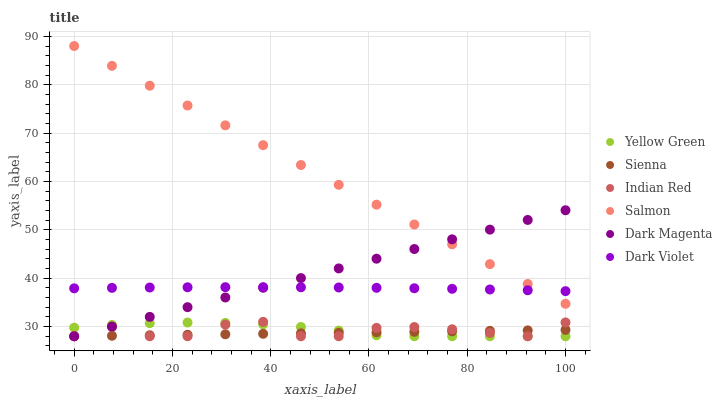Does Sienna have the minimum area under the curve?
Answer yes or no. Yes. Does Salmon have the maximum area under the curve?
Answer yes or no. Yes. Does Dark Violet have the minimum area under the curve?
Answer yes or no. No. Does Dark Violet have the maximum area under the curve?
Answer yes or no. No. Is Sienna the smoothest?
Answer yes or no. Yes. Is Indian Red the roughest?
Answer yes or no. Yes. Is Salmon the smoothest?
Answer yes or no. No. Is Salmon the roughest?
Answer yes or no. No. Does Yellow Green have the lowest value?
Answer yes or no. Yes. Does Salmon have the lowest value?
Answer yes or no. No. Does Salmon have the highest value?
Answer yes or no. Yes. Does Dark Violet have the highest value?
Answer yes or no. No. Is Indian Red less than Salmon?
Answer yes or no. Yes. Is Salmon greater than Indian Red?
Answer yes or no. Yes. Does Indian Red intersect Dark Magenta?
Answer yes or no. Yes. Is Indian Red less than Dark Magenta?
Answer yes or no. No. Is Indian Red greater than Dark Magenta?
Answer yes or no. No. Does Indian Red intersect Salmon?
Answer yes or no. No. 